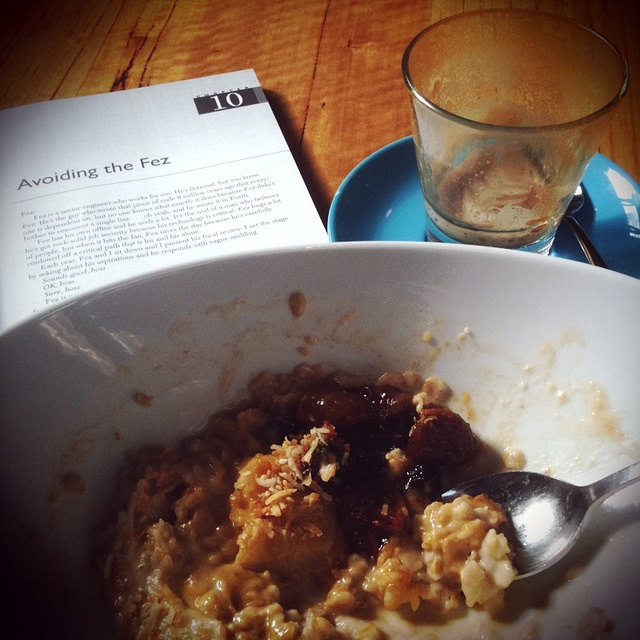Describe the objects in this image and their specific colors. I can see bowl in black, gray, maroon, and lightgray tones, book in black, white, darkgray, lightgray, and gray tones, cup in black, brown, maroon, and tan tones, spoon in black, gray, lightgray, and darkgray tones, and spoon in black, gray, and white tones in this image. 